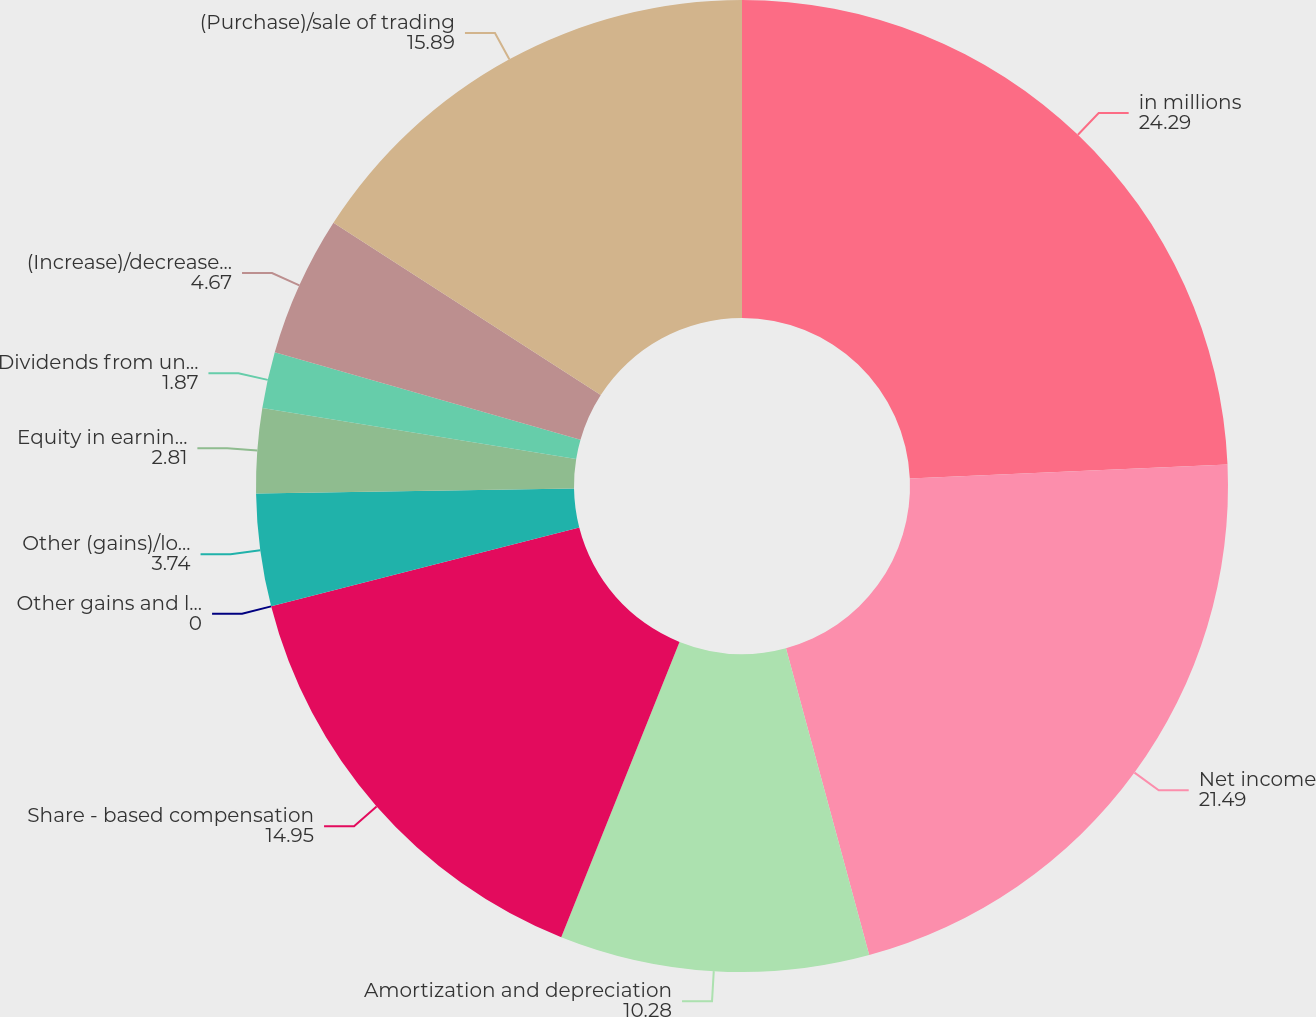<chart> <loc_0><loc_0><loc_500><loc_500><pie_chart><fcel>in millions<fcel>Net income<fcel>Amortization and depreciation<fcel>Share - based compensation<fcel>Other gains and losses net<fcel>Other (gains)/losses of CIP<fcel>Equity in earnings of<fcel>Dividends from unconsolidated<fcel>(Increase)/decrease in cash<fcel>(Purchase)/sale of trading<nl><fcel>24.29%<fcel>21.49%<fcel>10.28%<fcel>14.95%<fcel>0.0%<fcel>3.74%<fcel>2.81%<fcel>1.87%<fcel>4.67%<fcel>15.89%<nl></chart> 